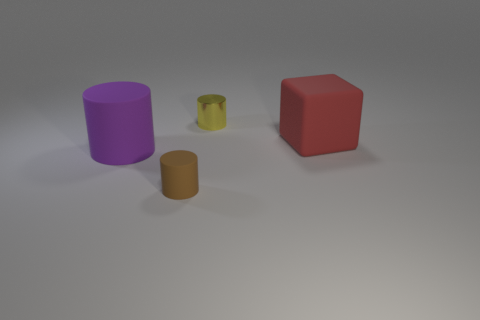Add 4 large red metallic blocks. How many objects exist? 8 Subtract all cubes. How many objects are left? 3 Subtract 0 yellow spheres. How many objects are left? 4 Subtract all purple things. Subtract all tiny cyan metal cylinders. How many objects are left? 3 Add 3 tiny yellow metallic things. How many tiny yellow metallic things are left? 4 Add 3 matte blocks. How many matte blocks exist? 4 